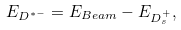<formula> <loc_0><loc_0><loc_500><loc_500>E _ { D ^ { * - } } = E _ { B e a m } - E _ { D _ { s } ^ { + } } ,</formula> 